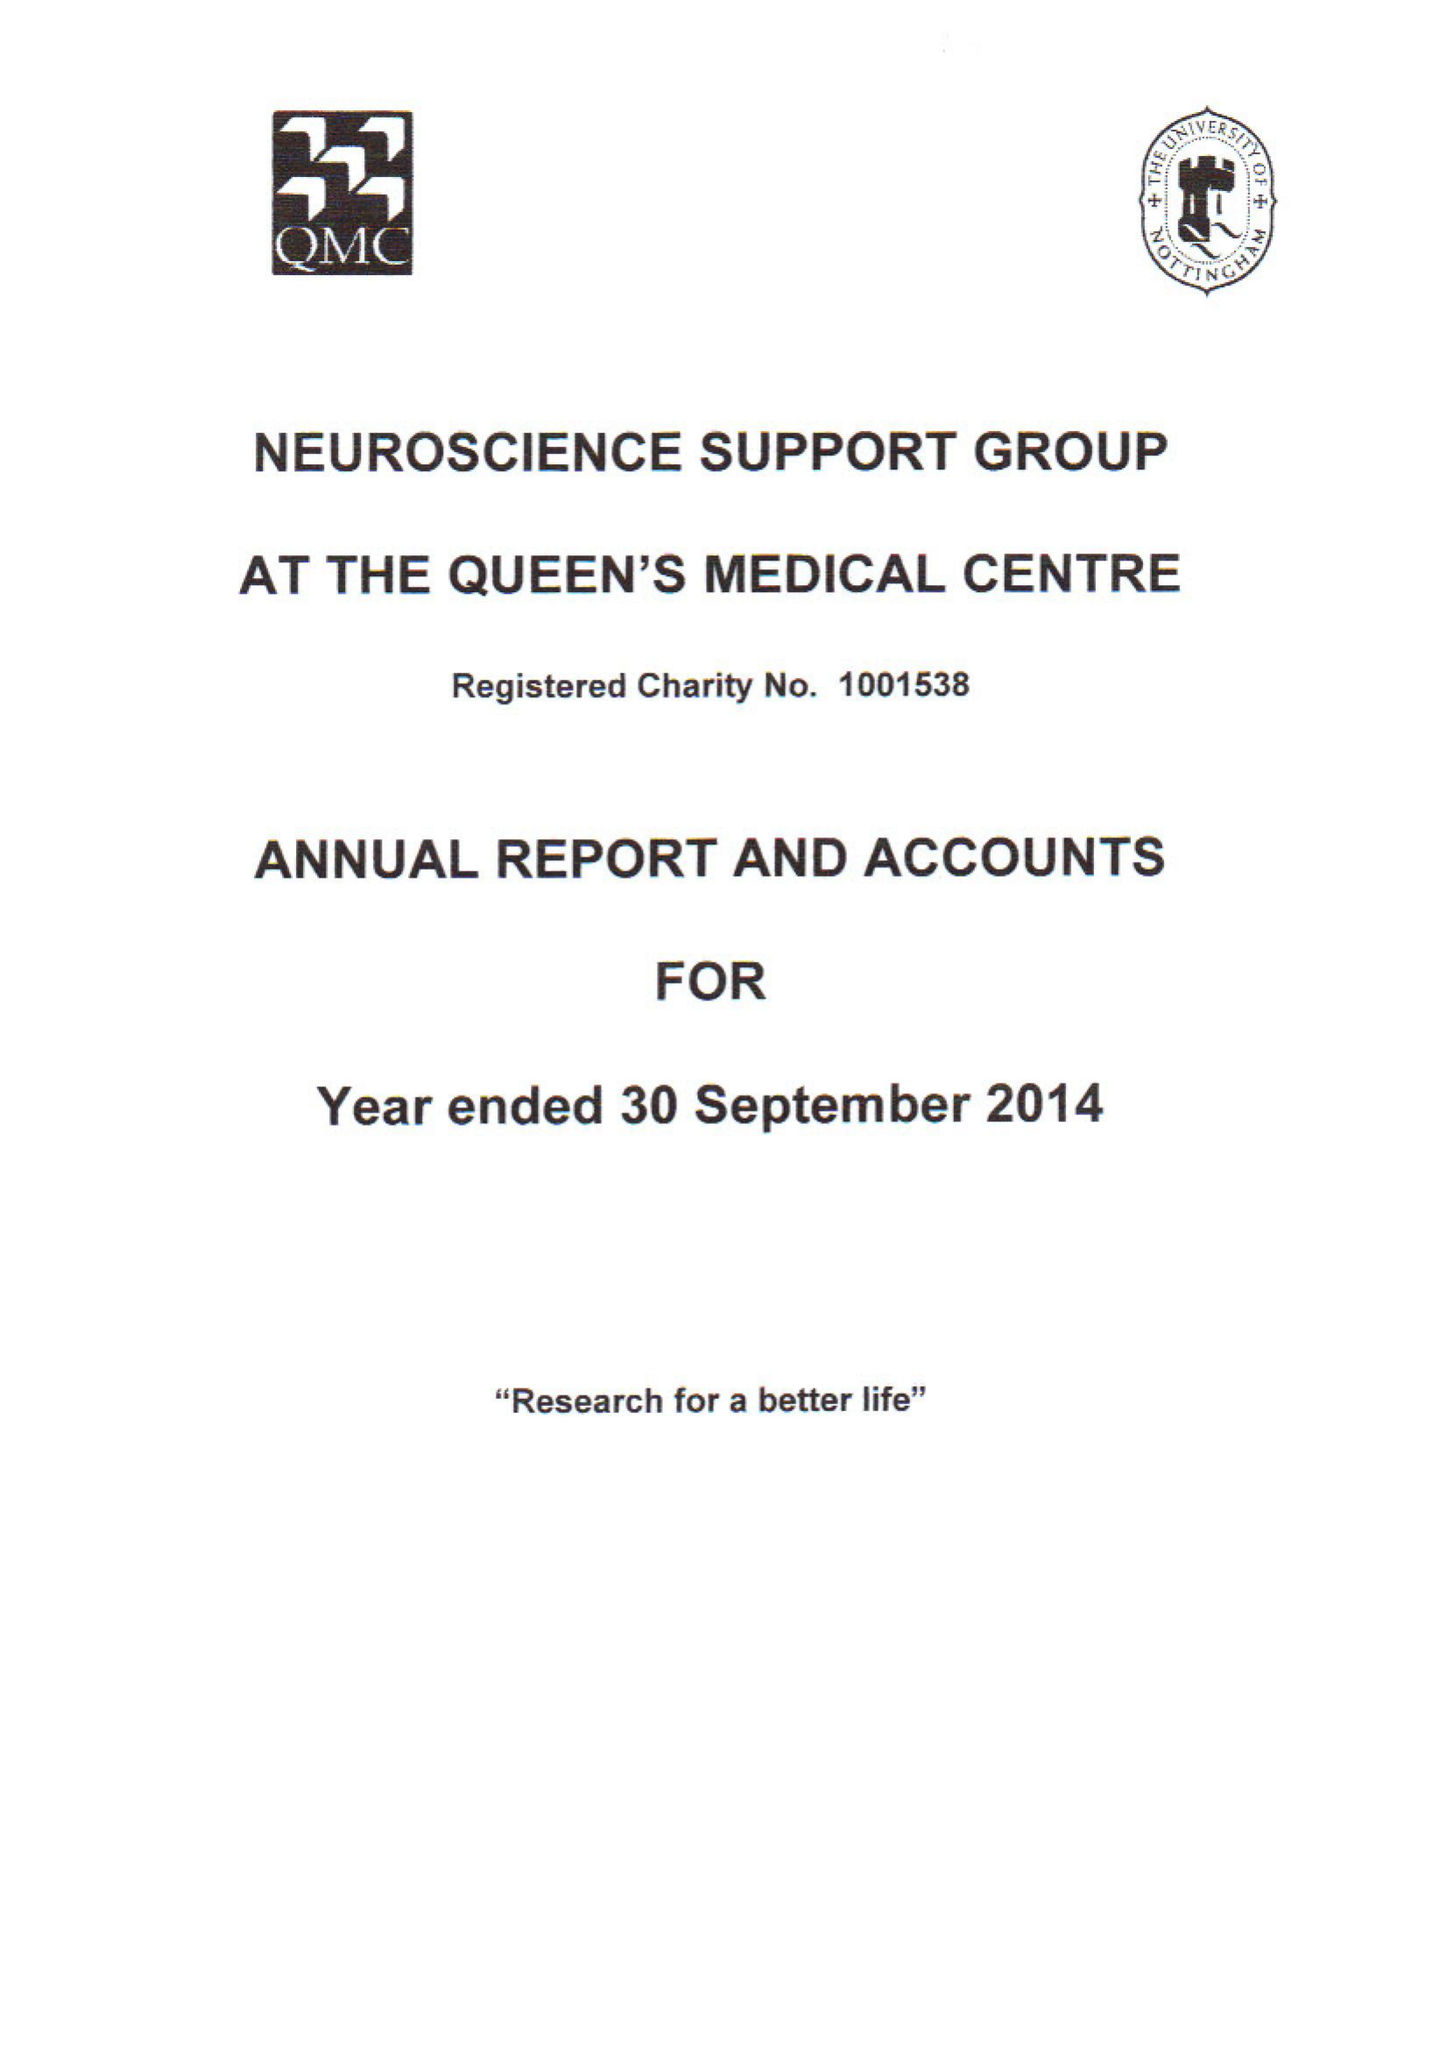What is the value for the address__post_town?
Answer the question using a single word or phrase. NOTTINGHAM 